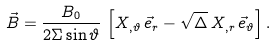<formula> <loc_0><loc_0><loc_500><loc_500>\vec { B } = \frac { B _ { 0 } } { 2 \Sigma \sin \vartheta } \, \left [ X _ { , \vartheta } \, \vec { e } _ { r } - \sqrt { \Delta } \, X _ { , r } \, \vec { e } _ { \vartheta } \right ] .</formula> 